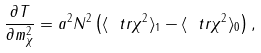Convert formula to latex. <formula><loc_0><loc_0><loc_500><loc_500>\frac { \partial T } { \partial m _ { \chi } ^ { 2 } } = a ^ { 2 } N ^ { 2 } \left ( \langle \ t r \chi ^ { 2 } \rangle _ { 1 } - \langle \ t r \chi ^ { 2 } \rangle _ { 0 } \right ) ,</formula> 